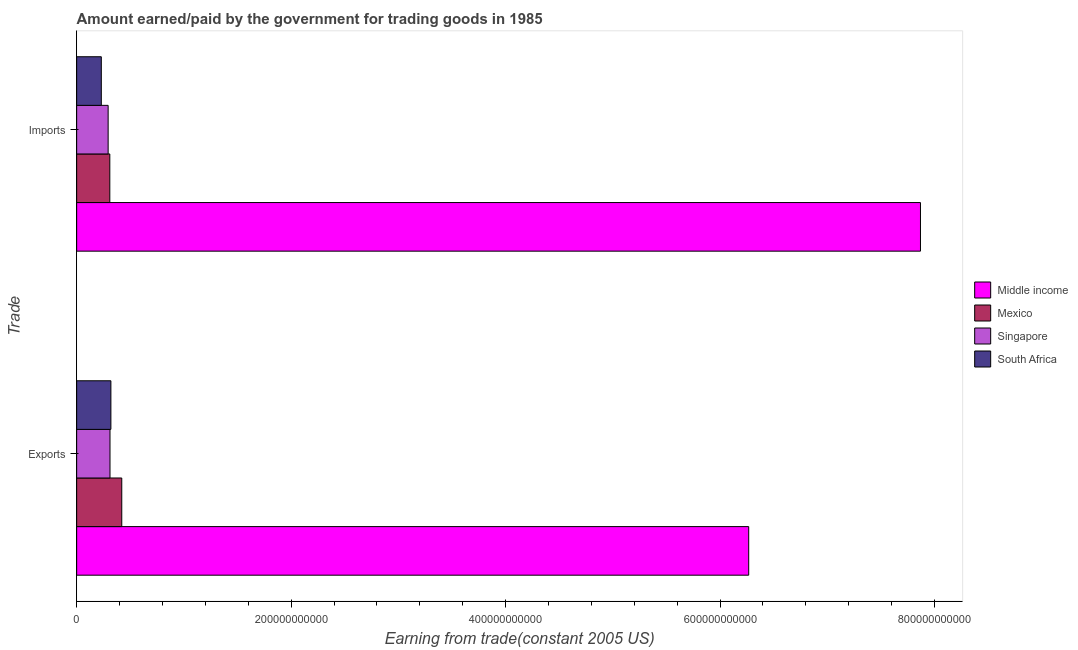How many different coloured bars are there?
Keep it short and to the point. 4. Are the number of bars per tick equal to the number of legend labels?
Your answer should be very brief. Yes. Are the number of bars on each tick of the Y-axis equal?
Provide a short and direct response. Yes. How many bars are there on the 2nd tick from the bottom?
Ensure brevity in your answer.  4. What is the label of the 1st group of bars from the top?
Keep it short and to the point. Imports. What is the amount earned from exports in South Africa?
Your answer should be compact. 3.19e+1. Across all countries, what is the maximum amount earned from exports?
Offer a terse response. 6.27e+11. Across all countries, what is the minimum amount earned from exports?
Your response must be concise. 3.11e+1. In which country was the amount earned from exports minimum?
Give a very brief answer. Singapore. What is the total amount earned from exports in the graph?
Offer a very short reply. 7.32e+11. What is the difference between the amount earned from exports in Singapore and that in Middle income?
Offer a very short reply. -5.96e+11. What is the difference between the amount earned from exports in South Africa and the amount paid for imports in Middle income?
Make the answer very short. -7.55e+11. What is the average amount paid for imports per country?
Provide a succinct answer. 2.18e+11. What is the difference between the amount paid for imports and amount earned from exports in Mexico?
Ensure brevity in your answer.  -1.12e+1. In how many countries, is the amount earned from exports greater than 520000000000 US$?
Your answer should be compact. 1. What is the ratio of the amount earned from exports in Mexico to that in South Africa?
Keep it short and to the point. 1.32. In how many countries, is the amount paid for imports greater than the average amount paid for imports taken over all countries?
Your response must be concise. 1. What does the 4th bar from the bottom in Exports represents?
Provide a succinct answer. South Africa. How many countries are there in the graph?
Give a very brief answer. 4. What is the difference between two consecutive major ticks on the X-axis?
Make the answer very short. 2.00e+11. Are the values on the major ticks of X-axis written in scientific E-notation?
Your answer should be compact. No. Does the graph contain grids?
Make the answer very short. No. How are the legend labels stacked?
Offer a terse response. Vertical. What is the title of the graph?
Provide a succinct answer. Amount earned/paid by the government for trading goods in 1985. What is the label or title of the X-axis?
Your answer should be very brief. Earning from trade(constant 2005 US). What is the label or title of the Y-axis?
Provide a succinct answer. Trade. What is the Earning from trade(constant 2005 US) of Middle income in Exports?
Offer a very short reply. 6.27e+11. What is the Earning from trade(constant 2005 US) in Mexico in Exports?
Offer a very short reply. 4.21e+1. What is the Earning from trade(constant 2005 US) in Singapore in Exports?
Give a very brief answer. 3.11e+1. What is the Earning from trade(constant 2005 US) of South Africa in Exports?
Your answer should be very brief. 3.19e+1. What is the Earning from trade(constant 2005 US) of Middle income in Imports?
Offer a very short reply. 7.87e+11. What is the Earning from trade(constant 2005 US) in Mexico in Imports?
Offer a very short reply. 3.09e+1. What is the Earning from trade(constant 2005 US) in Singapore in Imports?
Your response must be concise. 2.94e+1. What is the Earning from trade(constant 2005 US) in South Africa in Imports?
Offer a very short reply. 2.30e+1. Across all Trade, what is the maximum Earning from trade(constant 2005 US) in Middle income?
Your answer should be very brief. 7.87e+11. Across all Trade, what is the maximum Earning from trade(constant 2005 US) of Mexico?
Provide a succinct answer. 4.21e+1. Across all Trade, what is the maximum Earning from trade(constant 2005 US) in Singapore?
Offer a terse response. 3.11e+1. Across all Trade, what is the maximum Earning from trade(constant 2005 US) in South Africa?
Keep it short and to the point. 3.19e+1. Across all Trade, what is the minimum Earning from trade(constant 2005 US) of Middle income?
Your answer should be compact. 6.27e+11. Across all Trade, what is the minimum Earning from trade(constant 2005 US) in Mexico?
Make the answer very short. 3.09e+1. Across all Trade, what is the minimum Earning from trade(constant 2005 US) of Singapore?
Ensure brevity in your answer.  2.94e+1. Across all Trade, what is the minimum Earning from trade(constant 2005 US) in South Africa?
Provide a short and direct response. 2.30e+1. What is the total Earning from trade(constant 2005 US) in Middle income in the graph?
Offer a very short reply. 1.41e+12. What is the total Earning from trade(constant 2005 US) of Mexico in the graph?
Provide a succinct answer. 7.30e+1. What is the total Earning from trade(constant 2005 US) of Singapore in the graph?
Offer a terse response. 6.04e+1. What is the total Earning from trade(constant 2005 US) of South Africa in the graph?
Ensure brevity in your answer.  5.49e+1. What is the difference between the Earning from trade(constant 2005 US) of Middle income in Exports and that in Imports?
Provide a short and direct response. -1.60e+11. What is the difference between the Earning from trade(constant 2005 US) in Mexico in Exports and that in Imports?
Provide a short and direct response. 1.12e+1. What is the difference between the Earning from trade(constant 2005 US) of Singapore in Exports and that in Imports?
Ensure brevity in your answer.  1.73e+09. What is the difference between the Earning from trade(constant 2005 US) of South Africa in Exports and that in Imports?
Provide a succinct answer. 8.93e+09. What is the difference between the Earning from trade(constant 2005 US) of Middle income in Exports and the Earning from trade(constant 2005 US) of Mexico in Imports?
Your answer should be very brief. 5.96e+11. What is the difference between the Earning from trade(constant 2005 US) of Middle income in Exports and the Earning from trade(constant 2005 US) of Singapore in Imports?
Your answer should be very brief. 5.97e+11. What is the difference between the Earning from trade(constant 2005 US) of Middle income in Exports and the Earning from trade(constant 2005 US) of South Africa in Imports?
Provide a succinct answer. 6.04e+11. What is the difference between the Earning from trade(constant 2005 US) of Mexico in Exports and the Earning from trade(constant 2005 US) of Singapore in Imports?
Offer a very short reply. 1.27e+1. What is the difference between the Earning from trade(constant 2005 US) in Mexico in Exports and the Earning from trade(constant 2005 US) in South Africa in Imports?
Make the answer very short. 1.91e+1. What is the difference between the Earning from trade(constant 2005 US) in Singapore in Exports and the Earning from trade(constant 2005 US) in South Africa in Imports?
Offer a terse response. 8.10e+09. What is the average Earning from trade(constant 2005 US) in Middle income per Trade?
Your response must be concise. 7.07e+11. What is the average Earning from trade(constant 2005 US) of Mexico per Trade?
Provide a short and direct response. 3.65e+1. What is the average Earning from trade(constant 2005 US) of Singapore per Trade?
Offer a very short reply. 3.02e+1. What is the average Earning from trade(constant 2005 US) of South Africa per Trade?
Your answer should be very brief. 2.75e+1. What is the difference between the Earning from trade(constant 2005 US) in Middle income and Earning from trade(constant 2005 US) in Mexico in Exports?
Make the answer very short. 5.85e+11. What is the difference between the Earning from trade(constant 2005 US) of Middle income and Earning from trade(constant 2005 US) of Singapore in Exports?
Provide a succinct answer. 5.96e+11. What is the difference between the Earning from trade(constant 2005 US) of Middle income and Earning from trade(constant 2005 US) of South Africa in Exports?
Your answer should be compact. 5.95e+11. What is the difference between the Earning from trade(constant 2005 US) in Mexico and Earning from trade(constant 2005 US) in Singapore in Exports?
Your response must be concise. 1.10e+1. What is the difference between the Earning from trade(constant 2005 US) in Mexico and Earning from trade(constant 2005 US) in South Africa in Exports?
Offer a terse response. 1.01e+1. What is the difference between the Earning from trade(constant 2005 US) in Singapore and Earning from trade(constant 2005 US) in South Africa in Exports?
Offer a terse response. -8.28e+08. What is the difference between the Earning from trade(constant 2005 US) in Middle income and Earning from trade(constant 2005 US) in Mexico in Imports?
Provide a succinct answer. 7.56e+11. What is the difference between the Earning from trade(constant 2005 US) in Middle income and Earning from trade(constant 2005 US) in Singapore in Imports?
Your answer should be compact. 7.58e+11. What is the difference between the Earning from trade(constant 2005 US) in Middle income and Earning from trade(constant 2005 US) in South Africa in Imports?
Ensure brevity in your answer.  7.64e+11. What is the difference between the Earning from trade(constant 2005 US) of Mexico and Earning from trade(constant 2005 US) of Singapore in Imports?
Give a very brief answer. 1.56e+09. What is the difference between the Earning from trade(constant 2005 US) in Mexico and Earning from trade(constant 2005 US) in South Africa in Imports?
Your answer should be compact. 7.92e+09. What is the difference between the Earning from trade(constant 2005 US) of Singapore and Earning from trade(constant 2005 US) of South Africa in Imports?
Your response must be concise. 6.37e+09. What is the ratio of the Earning from trade(constant 2005 US) in Middle income in Exports to that in Imports?
Ensure brevity in your answer.  0.8. What is the ratio of the Earning from trade(constant 2005 US) of Mexico in Exports to that in Imports?
Your response must be concise. 1.36. What is the ratio of the Earning from trade(constant 2005 US) in Singapore in Exports to that in Imports?
Provide a short and direct response. 1.06. What is the ratio of the Earning from trade(constant 2005 US) of South Africa in Exports to that in Imports?
Provide a short and direct response. 1.39. What is the difference between the highest and the second highest Earning from trade(constant 2005 US) of Middle income?
Offer a very short reply. 1.60e+11. What is the difference between the highest and the second highest Earning from trade(constant 2005 US) of Mexico?
Give a very brief answer. 1.12e+1. What is the difference between the highest and the second highest Earning from trade(constant 2005 US) of Singapore?
Your response must be concise. 1.73e+09. What is the difference between the highest and the second highest Earning from trade(constant 2005 US) in South Africa?
Offer a terse response. 8.93e+09. What is the difference between the highest and the lowest Earning from trade(constant 2005 US) of Middle income?
Your response must be concise. 1.60e+11. What is the difference between the highest and the lowest Earning from trade(constant 2005 US) of Mexico?
Provide a short and direct response. 1.12e+1. What is the difference between the highest and the lowest Earning from trade(constant 2005 US) of Singapore?
Your answer should be compact. 1.73e+09. What is the difference between the highest and the lowest Earning from trade(constant 2005 US) of South Africa?
Your answer should be very brief. 8.93e+09. 